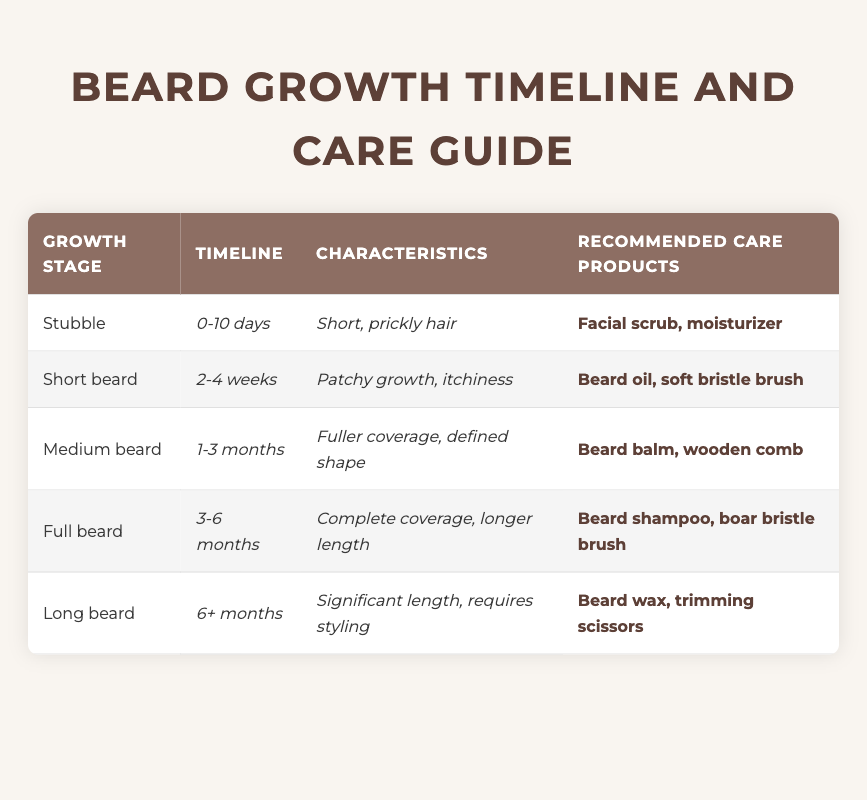What care products are recommended for a stubble beard? In the "Stubble" row, the recommended care products listed are "Facial scrub, moisturizer." Therefore, these are the products you should use for stubble.
Answer: Facial scrub, moisturizer What characteristics define a medium beard? In the "Medium beard" row, the characteristics listed are "Fuller coverage, defined shape." This indicates the typical look and feel of a medium beard.
Answer: Fuller coverage, defined shape Is beard oil recommended for a full beard? According to the table, the recommended care products for a "Full beard" include "Beard shampoo, boar bristle brush," and beard oil is not mentioned, so the answer is no.
Answer: No How long does it take to reach the short beard stage? The timeline for the "Short beard" stage is "2-4 weeks." This indicates that it takes a minimum of 2 weeks and up to 4 weeks to reach this stage of beard growth.
Answer: 2-4 weeks What are the care product recommendations for a long beard? The "Long beard" row specifies "Beard wax, trimming scissors" as the recommended care products. This means that these products should be used for long beards.
Answer: Beard wax, trimming scissors Which beard stage requires beard balm? The "Medium beard" entry in the table recommends "Beard balm" as one of the care products. Therefore, the medium beard stage requires beard balm.
Answer: Medium beard Can you have a long beard if you are still within the timeline for a full beard? The timeline for a "Full beard" is 3-6 months, while a "Long beard" is classified as 6+ months, meaning you cannot have a long beard within the full beard timeline.
Answer: No What is the average duration across all beard growth stages? Calculating the total duration: Stubble (10 days, or ~0.33 months), Short beard (1.5 months), Medium beard (2 months), Full beard (3 months), Long beard (6+ months, estimated as 6 months) gives total of ~12.83 months. Dividing by 5 stages gives an average of ~2.57 months.
Answer: Approximately 2.57 months What growth stage comes immediately after stubble? Based on the timeline in the table, the growth stage that comes immediately after stubble (0-10 days) is the "Short beard" (2-4 weeks).
Answer: Short beard 